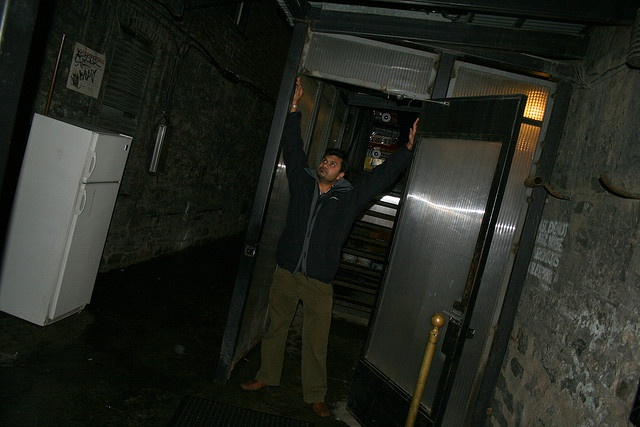Describe the objects in this image and their specific colors. I can see people in black, maroon, and gray tones and refrigerator in black and gray tones in this image. 